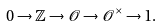<formula> <loc_0><loc_0><loc_500><loc_500>0 \to \mathbb { Z } \to \mathcal { O } \to \mathcal { O } ^ { \times } \to 1 .</formula> 